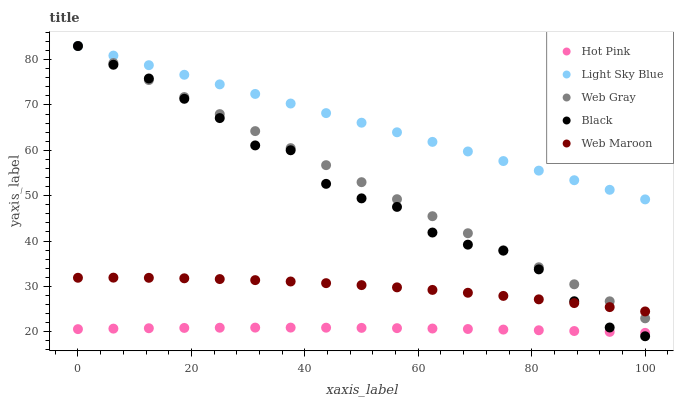Does Hot Pink have the minimum area under the curve?
Answer yes or no. Yes. Does Light Sky Blue have the maximum area under the curve?
Answer yes or no. Yes. Does Black have the minimum area under the curve?
Answer yes or no. No. Does Black have the maximum area under the curve?
Answer yes or no. No. Is Light Sky Blue the smoothest?
Answer yes or no. Yes. Is Black the roughest?
Answer yes or no. Yes. Is Hot Pink the smoothest?
Answer yes or no. No. Is Hot Pink the roughest?
Answer yes or no. No. Does Black have the lowest value?
Answer yes or no. Yes. Does Hot Pink have the lowest value?
Answer yes or no. No. Does Light Sky Blue have the highest value?
Answer yes or no. Yes. Does Hot Pink have the highest value?
Answer yes or no. No. Is Hot Pink less than Web Gray?
Answer yes or no. Yes. Is Light Sky Blue greater than Hot Pink?
Answer yes or no. Yes. Does Black intersect Hot Pink?
Answer yes or no. Yes. Is Black less than Hot Pink?
Answer yes or no. No. Is Black greater than Hot Pink?
Answer yes or no. No. Does Hot Pink intersect Web Gray?
Answer yes or no. No. 